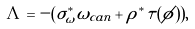Convert formula to latex. <formula><loc_0><loc_0><loc_500><loc_500>\Lambda = - ( \sigma _ { \omega } ^ { * } \omega _ { c a n } + \rho ^ { * } \tau ( \phi ) ) ,</formula> 